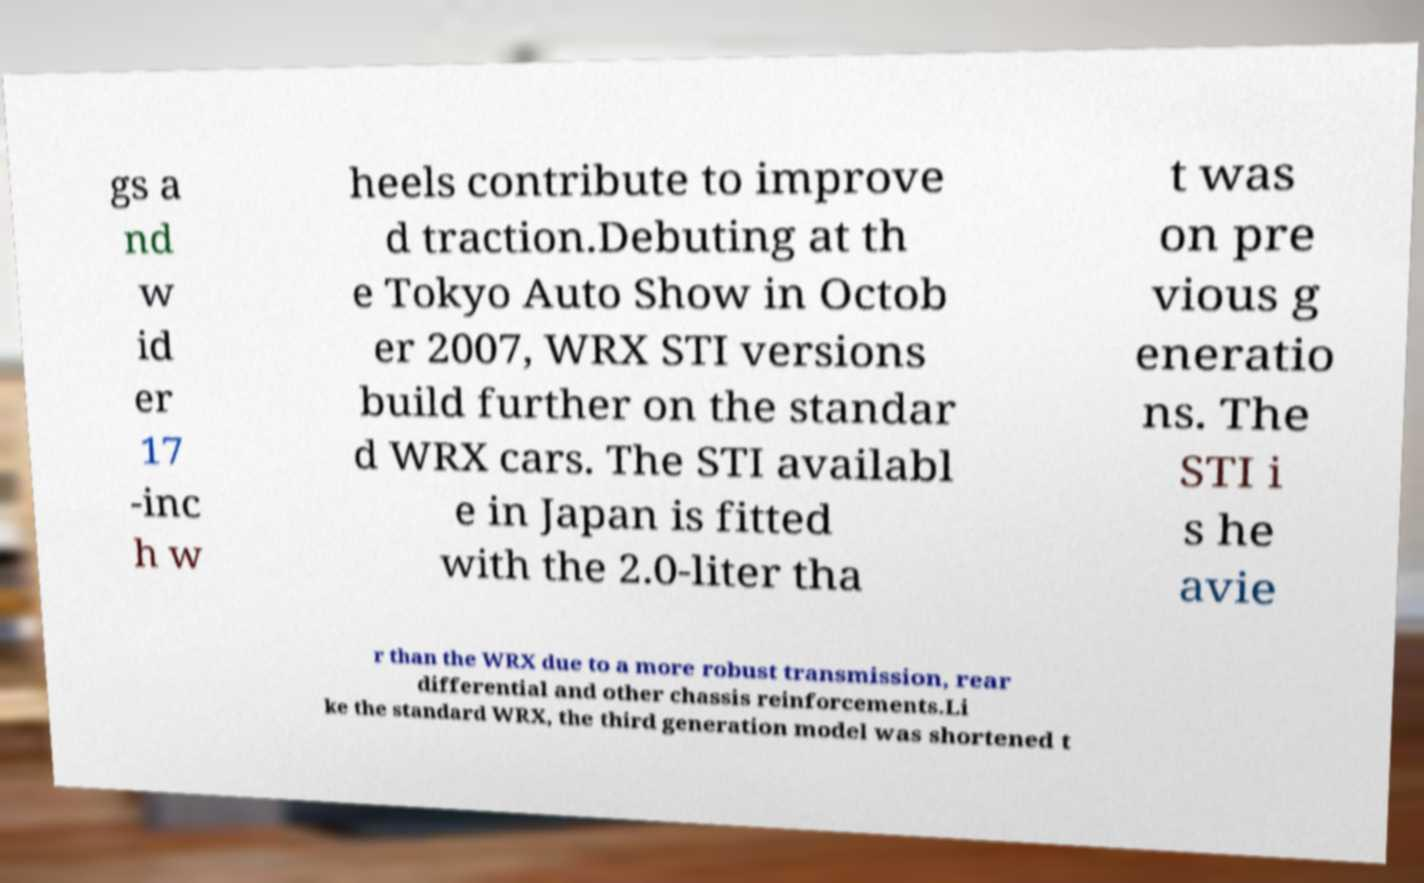For documentation purposes, I need the text within this image transcribed. Could you provide that? gs a nd w id er 17 -inc h w heels contribute to improve d traction.Debuting at th e Tokyo Auto Show in Octob er 2007, WRX STI versions build further on the standar d WRX cars. The STI availabl e in Japan is fitted with the 2.0-liter tha t was on pre vious g eneratio ns. The STI i s he avie r than the WRX due to a more robust transmission, rear differential and other chassis reinforcements.Li ke the standard WRX, the third generation model was shortened t 